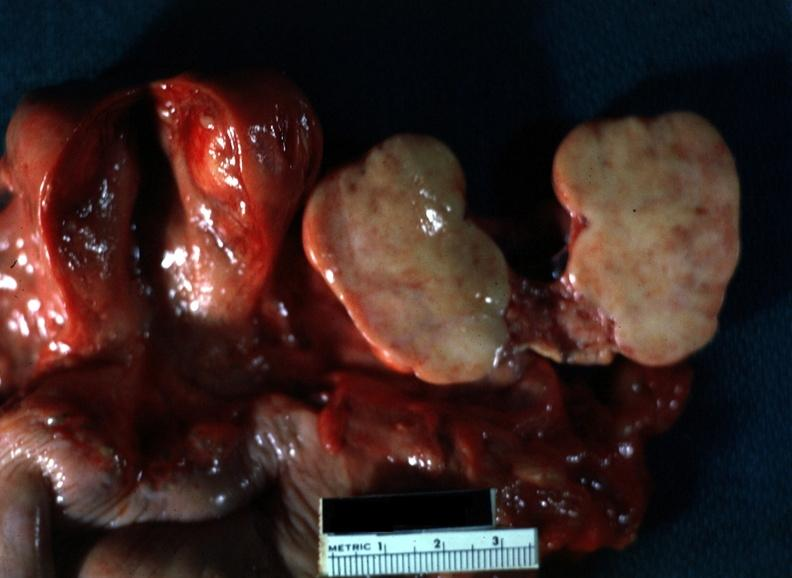s close-up of lesion sliced open like a book typical for this lesion with yellow foci evident view of all pelvic organ in slide?
Answer the question using a single word or phrase. Yes 